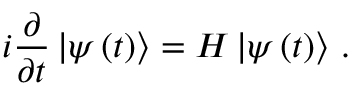<formula> <loc_0><loc_0><loc_500><loc_500>i \frac { \partial } { \partial t } \ m a t h i n n e r { | { \psi \left ( t \right ) } \rangle } = H \ m a t h i n n e r { | { \psi \left ( t \right ) } \rangle } \, .</formula> 